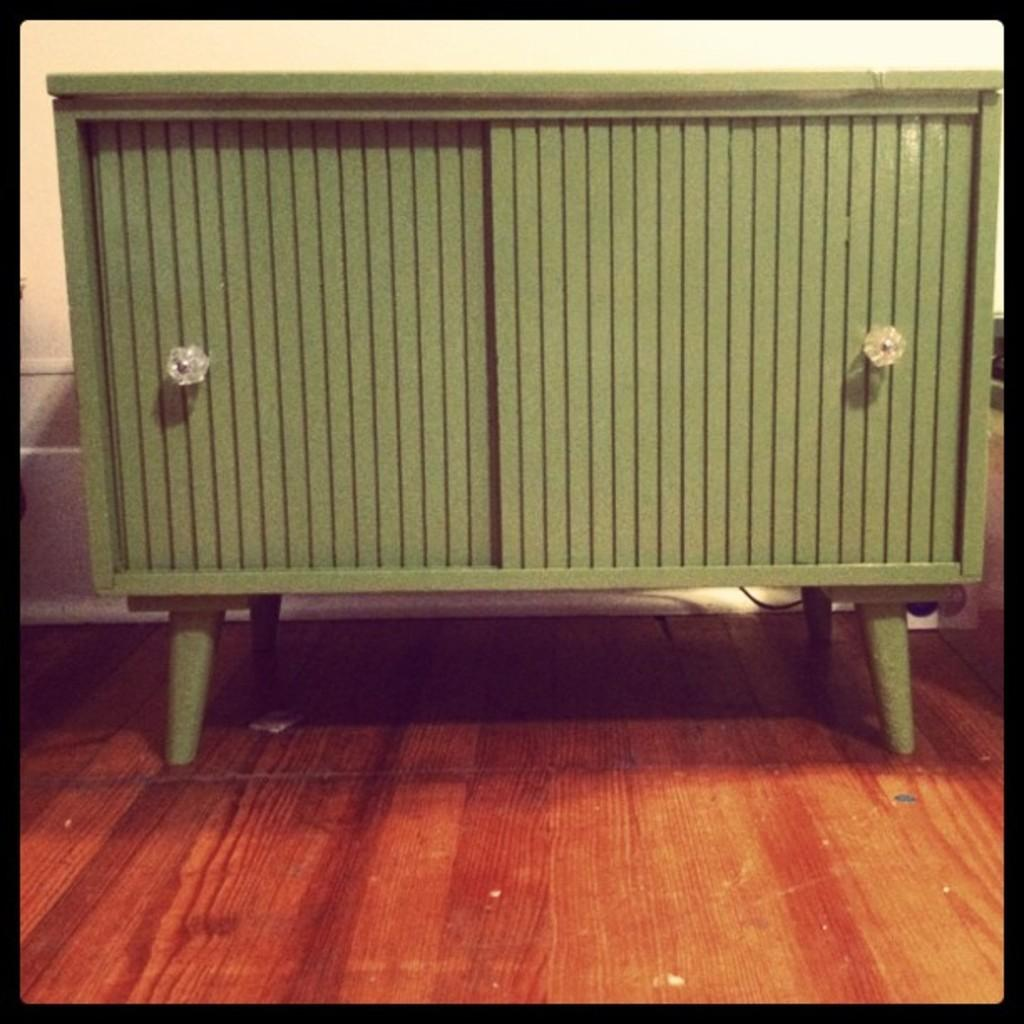What is the main object in the center of the image? There is a cupboard in the center of the image. What can be seen behind the cupboard? There is a wall visible in the background of the image. What is the surface on which the cupboard is placed? The floor is visible at the bottom of the image. Can you see a snail crawling on the wall in the image? There is no snail visible on the wall in the image. 